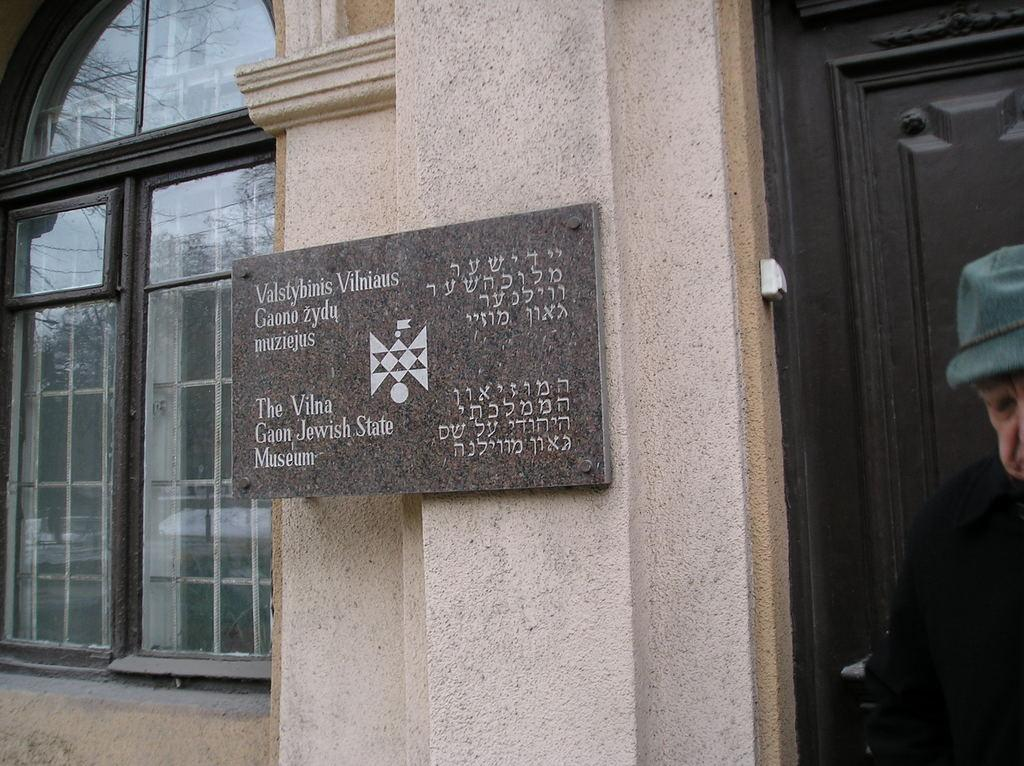What is located on the right side of the image? There is a man on the right side of the image. What can be seen in the background of the image? There is a building and a board placed on a wall in the background. What architectural features are visible in the image? There is a door and a window visible in the image. What type of vein can be seen running through the building in the image? There is no vein visible in the image; it is a building with a board placed on a wall in the background. Who is the creator of the building depicted in the image? The creator of the building is not mentioned or visible in the image. 